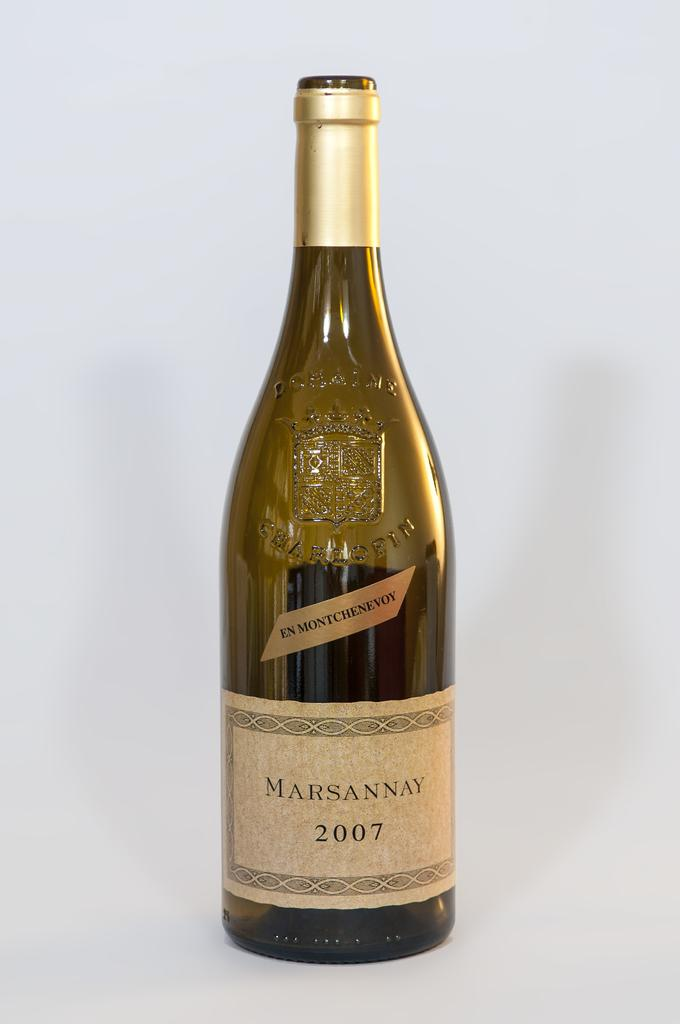<image>
Give a short and clear explanation of the subsequent image. a wine bottle with a label on it that says ' marsannay 2007' 